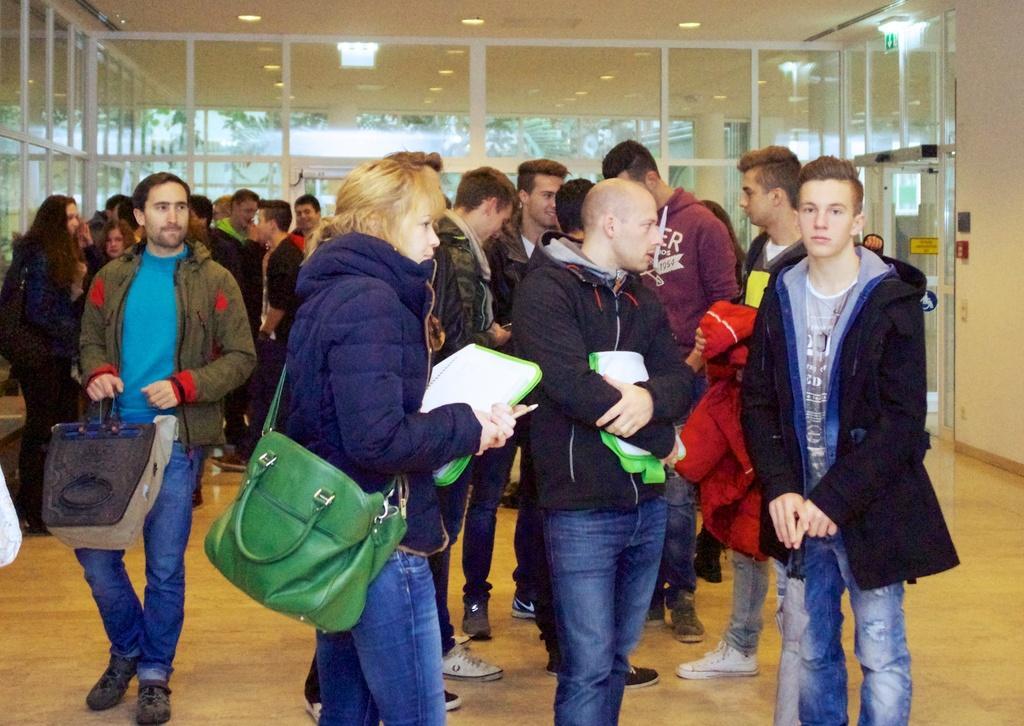Describe this image in one or two sentences. Here we can see that a group of people standing on the floor, and at back there is the door, and at top there are the lights. 